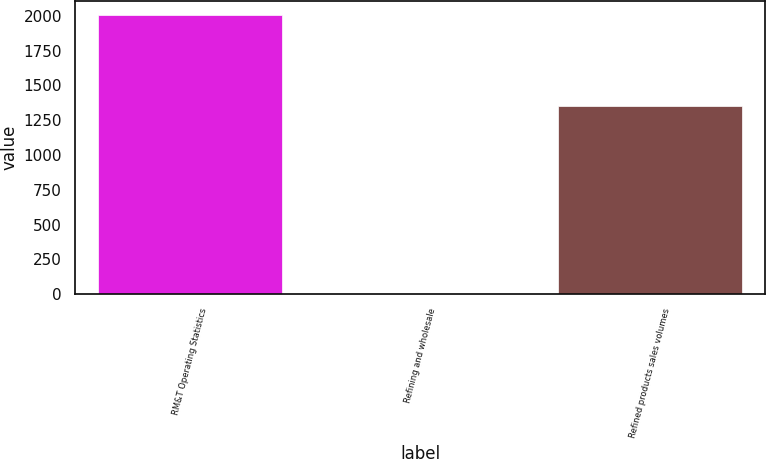Convert chart to OTSL. <chart><loc_0><loc_0><loc_500><loc_500><bar_chart><fcel>RM&T Operating Statistics<fcel>Refining and wholesale<fcel>Refined products sales volumes<nl><fcel>2008<fcel>0.12<fcel>1352<nl></chart> 